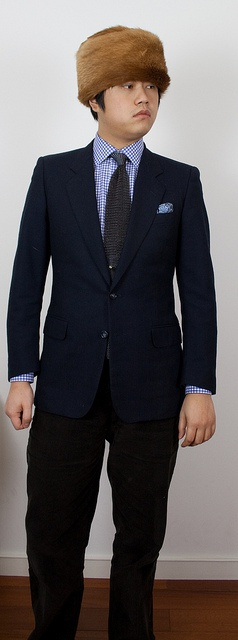Describe the objects in this image and their specific colors. I can see people in black, lightgray, gray, and tan tones and tie in lightgray, black, and gray tones in this image. 